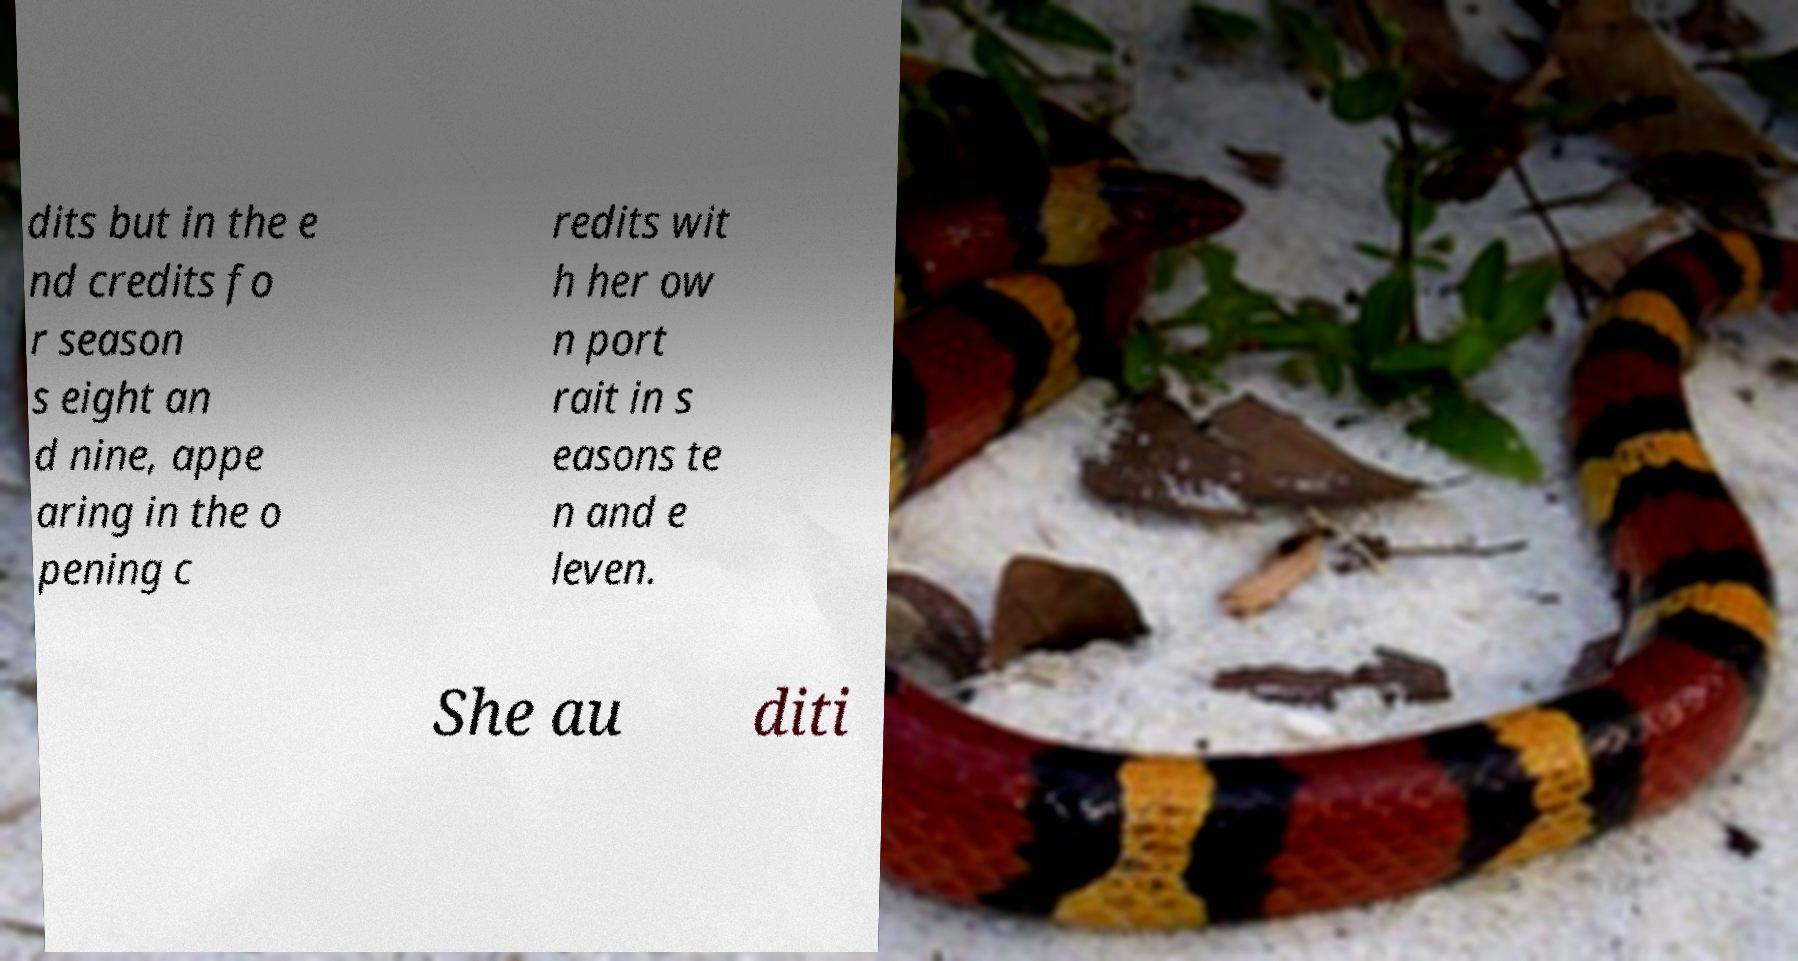What messages or text are displayed in this image? I need them in a readable, typed format. dits but in the e nd credits fo r season s eight an d nine, appe aring in the o pening c redits wit h her ow n port rait in s easons te n and e leven. She au diti 